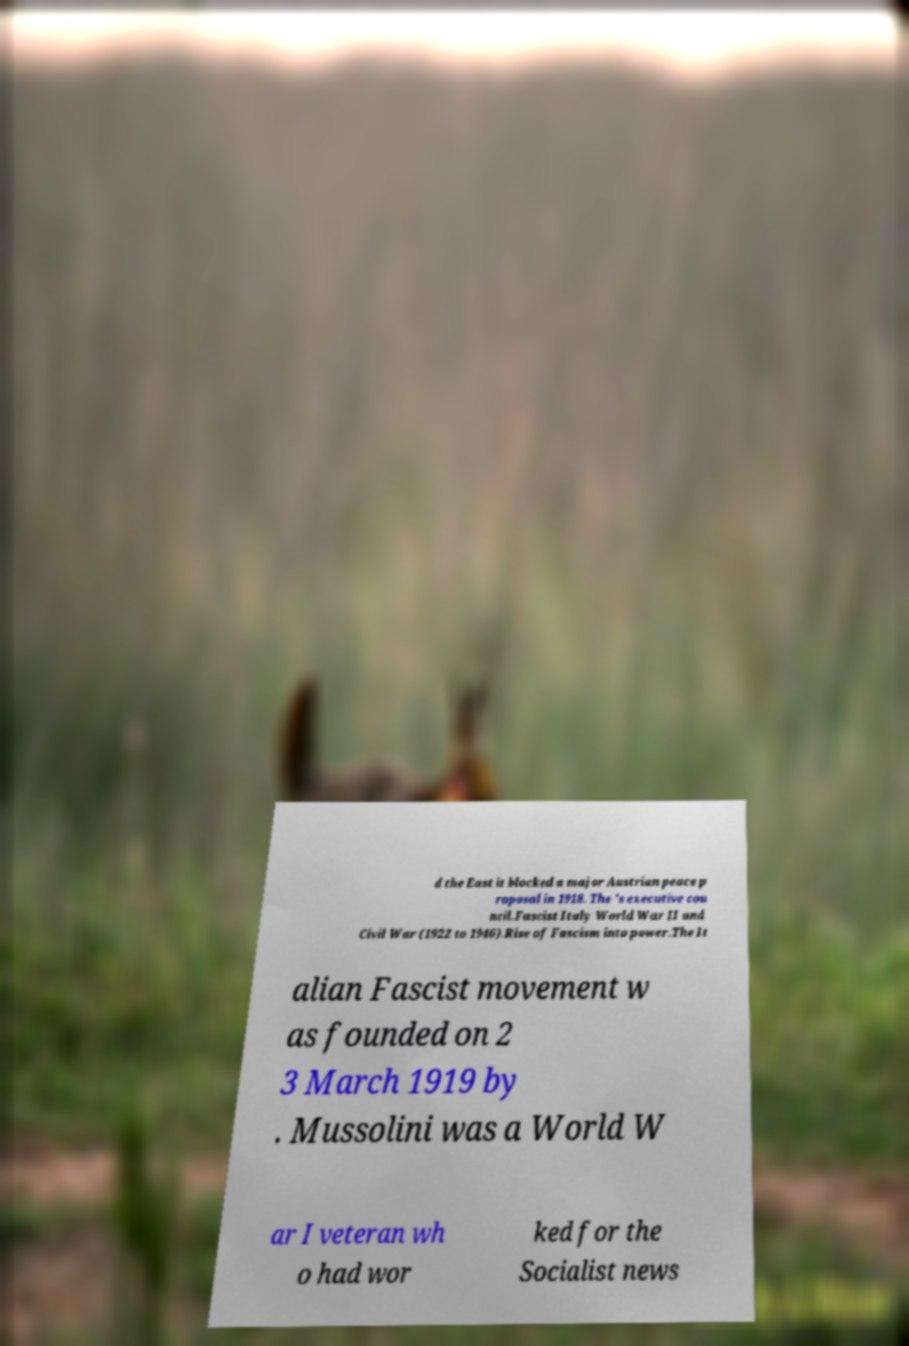Please read and relay the text visible in this image. What does it say? d the East it blocked a major Austrian peace p roposal in 1918. The 's executive cou ncil.Fascist Italy World War II and Civil War (1922 to 1946).Rise of Fascism into power.The It alian Fascist movement w as founded on 2 3 March 1919 by . Mussolini was a World W ar I veteran wh o had wor ked for the Socialist news 